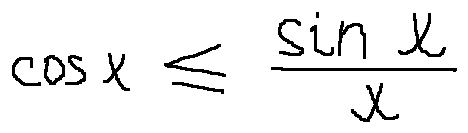<formula> <loc_0><loc_0><loc_500><loc_500>\cos x \leq \frac { \sin x } { x }</formula> 